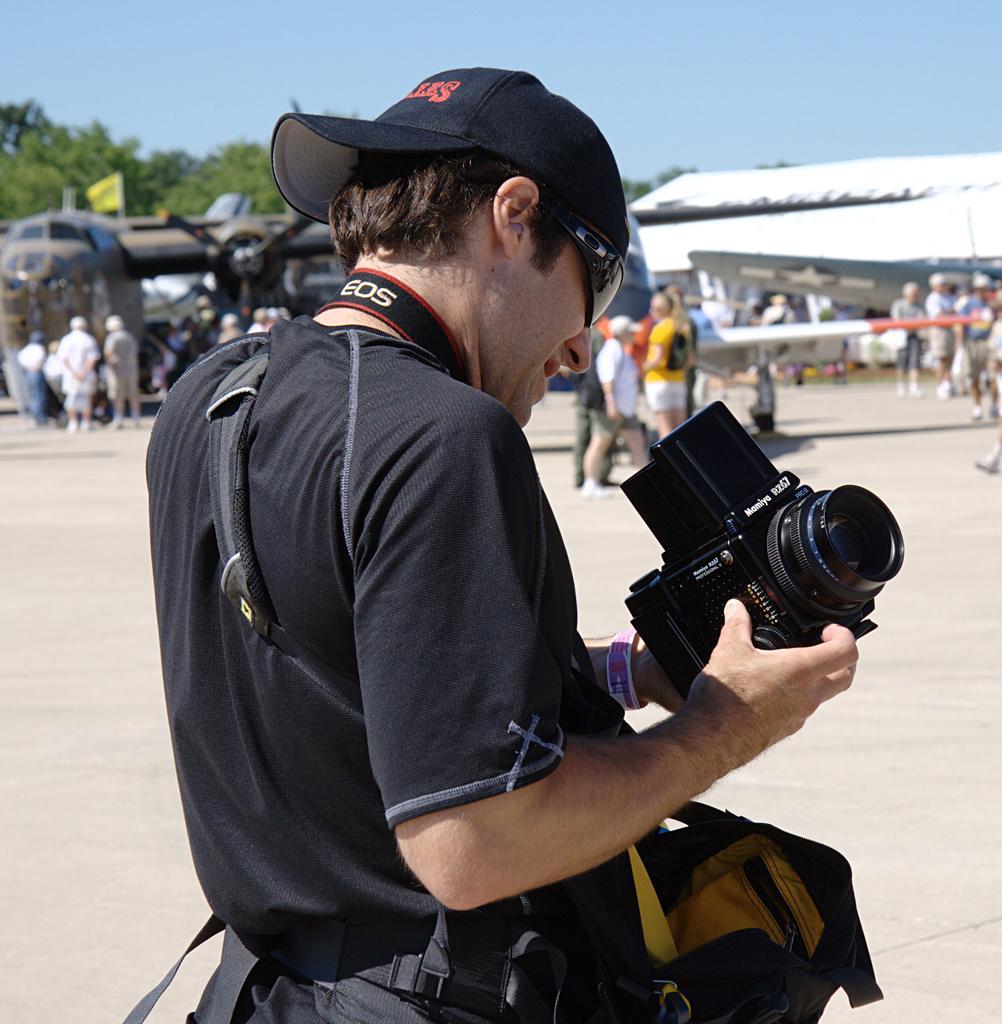How would you summarize this image in a sentence or two? In the picture we can see a man standing on the sand surface, he is with a black T-shirt and holding a camera and wearing a black cap and far away from him we can see some people are standing and some people are walking and behind them we can see some trees and sky. 